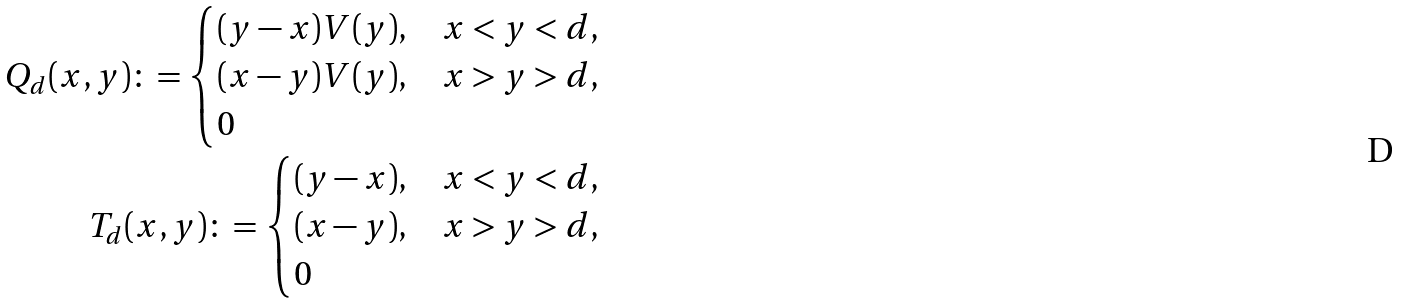Convert formula to latex. <formula><loc_0><loc_0><loc_500><loc_500>Q _ { d } ( x , y ) \colon = \begin{cases} ( y - x ) V ( y ) , & x < y < d , \\ ( x - y ) V ( y ) , & x > y > d , \\ 0 & \end{cases} \\ T _ { d } ( x , y ) \colon = \begin{cases} ( y - x ) , & x < y < d , \\ ( x - y ) , & x > y > d , \\ 0 & \end{cases}</formula> 